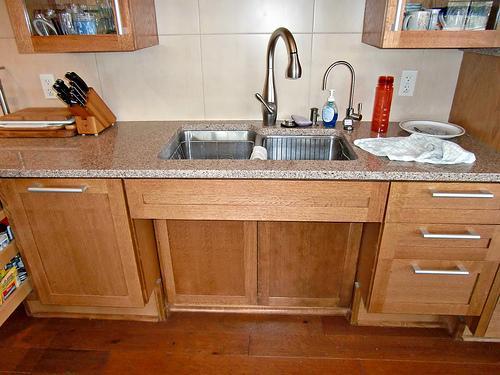Write a brief sentence summarizing the features found on the kitchen counter. The kitchen counter features a sink, faucet, soap bottle, water bottle, plate, towel, and rack of knives. Describe the appearance of the hand soap and its container. The hand soap is blue and is in a plastic bottle with a hand pump. Discuss an interaction between two objects in the image. The white dinner plate is resting on the kitchen counter, indicating that they serve the purpose of either preparing for a meal or storage after cleaning. What material is the kitchen sink made of and what color is it? The kitchen sink is made of silver metal. Count the number of kitchen handles visible in the image. There are four kitchen handles in total. Can you identify any part of an electrical system in the image? Yes, there is a white electric outlet on the wall. Perform a quality assessment of the image and suggest areas for improvement. The image is of decent quality but could benefit from clearer annotation of overlapping objects, such as the knives, water bottle, and soap dispenser. Provide a detailed caption for the image, including the main objects found within. A functional and organized kitchen featuring a silver metal sink, stainless steel faucet, plastic bottles of blue hand soap and water, a white dinner plate, a rack of knives, and dark wooden flooring. Please provide a brief description of the flooring in the room. The floor has a dark wooden finish. Analyze the sentiment of the scene portrayed in the image. The sentiment of the scene is neutral, as it depicts a well-organized and functional kitchen. List all the objects in the image. silver metal sink, stainless steel faucet, blue hand soap, red plastic water bottle, white dinner plate, white electric outlet, kitchen knife rack, cutting boards, kitchen cupboards, drawer handle, kia sign, white towel, white wall outlet, white tile, wooden floor, drinking bottle, cabinet handle, soap container, blue colored soap, dish cleaning rag, metal sink, white mug, red bottle, bottle with hand pump, wooden knife block, white plate, metal sink stopper, drawer handles, cabinet handle, knives, white cloth Is the green pan hanging from the pot rack over the stove in this kitchen? There is no mention of a green pan, pot rack, or a stove in the image information. The instruction is misleading because it refers to objects that do not exist in the image according to the given information. Identify any anomalies or unusual aspects in the image. There are multiple captions for the same object, such as the blue hand soap, Kia sign, and white plate. Describe the interaction between the sink, faucet, and blue hand soap. The sink, faucet, and blue hand soap are placed next to each other on a kitchen counter. The faucet is mounted on the sink, facilitating the flow of water. The soap is within reach for easy handwashing. I really like the marble pattern on the kitchen island; can you enhance its colors? There is no mention of a kitchen island or any marble pattern in the image information. The instruction is misleading as it assumes the presence of an island and a specific pattern that are nonexistent in the image. Choose the correct statement: A) There is white tile behind the sink. B) The sink is above the refrigerator. A) There is white tile behind the sink. What do you think about the artistically crafted wooden spice rack that's mounted on the wall near the knives? There is no mention of a wooden spice rack in the image information. The instruction is misleading as it refers to a nonexistent object in the picture. Rate the quality of the image on a scale from 1 to 5 (1 being the poorest quality and 5 being the highest quality). 4 Can you please suggest how to improve the lighting over the purple flower vase on the counter? There is no mention of a purple flower vase in the image information. The instruction is misleading because it implies there is a flower vase in the image, which is not true according to the given information. Describe the scene in the image. The image shows a kitchen with various objects such as a metal sink, kitchen knives, cutting boards, and dinner plate on the counter, and a red water bottle, white outlet, and blue hand soap nearby. The cupboards have a wood finish and there's a white tile backsplash. What are the attributes of the metal sink? silver color, set into the countertop, empty Can you guess what time the blue wall clock is showing near the kitchen sink? There is no mention of a blue wall clock in the image information. The instruction is misleading because it asks the reader to guess the time on a nonexistent clock in the image. Is there a positive or negative sentiment associated with this image? neutral Please add some green apples to the empty fruit bowl by the red water bottle. There is no mention of an empty fruit bowl in the image information. The instruction is misleading as it assumes the presence of a fruit bowl that is nonexistent in the image. Highlight the areas of the image where each object is present. sink: (156, 128, 102, 102), faucet: (252, 26, 50, 50), blue soap: (322, 88, 15, 15), white plate: (399, 118, 66, 66), cutting boards: (0, 105, 74, 74), knives: (52, 71, 64, 64), white cloth: (245, 140, 24, 24), white wall outlet: (37, 73, 19, 19), white tile: (2, 2, 460, 460), wooden floor: (0, 303, 498, 498) Select the best captions for the red bottle. a red plastic water bottle, orange plastic water bottle, red bottle on kitchen counter Determine any numbers or text visible in the image. There is no visible text or numbers in the image. 